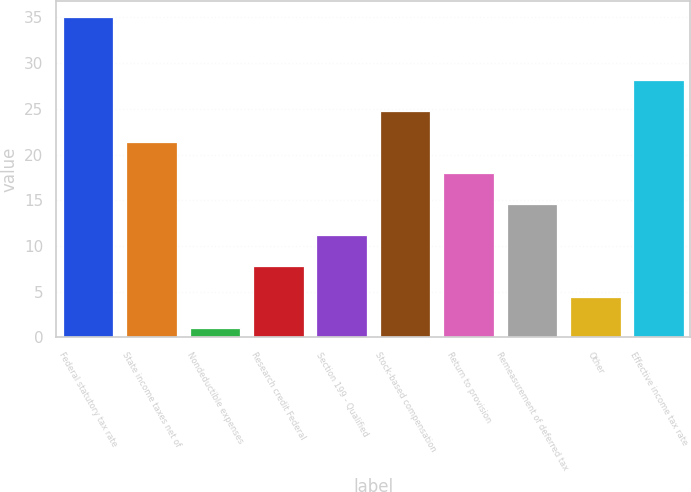Convert chart. <chart><loc_0><loc_0><loc_500><loc_500><bar_chart><fcel>Federal statutory tax rate<fcel>State income taxes net of<fcel>Nondeductible expenses<fcel>Research credit Federal<fcel>Section 199 - Qualified<fcel>Stock-based compensation<fcel>Return to provision<fcel>Remeasurement of deferred tax<fcel>Other<fcel>Effective income tax rate<nl><fcel>35<fcel>21.4<fcel>1<fcel>7.8<fcel>11.2<fcel>24.8<fcel>18<fcel>14.6<fcel>4.4<fcel>28.2<nl></chart> 